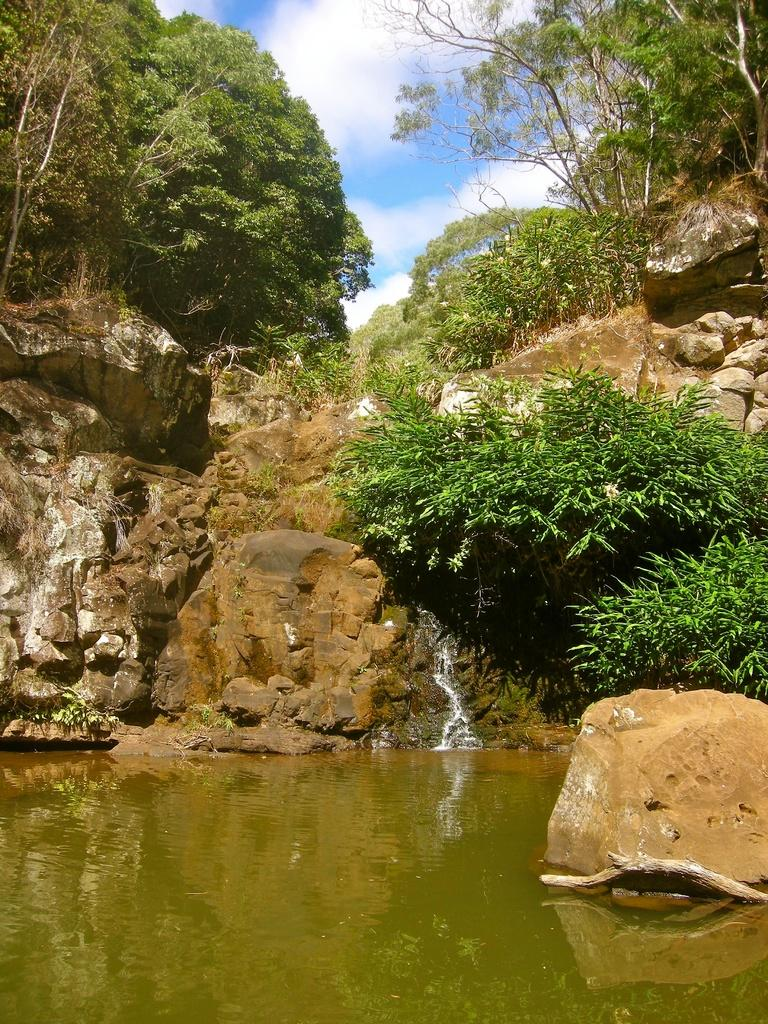What type of vegetation can be seen in the image? There are trees and plants in the image. What natural elements are present in the image? There are trees, plants, and waterstones in the image. What is visible in the sky in the image? The sky is visible in the image, and clouds are present. Where is the grandfather selling his goods in the image? There is no grandfather or market present in the image; it features trees, plants, waterstones, and a sky with clouds. 